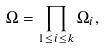Convert formula to latex. <formula><loc_0><loc_0><loc_500><loc_500>\Omega = \prod _ { 1 \leq i \leq k } \Omega _ { i } ,</formula> 